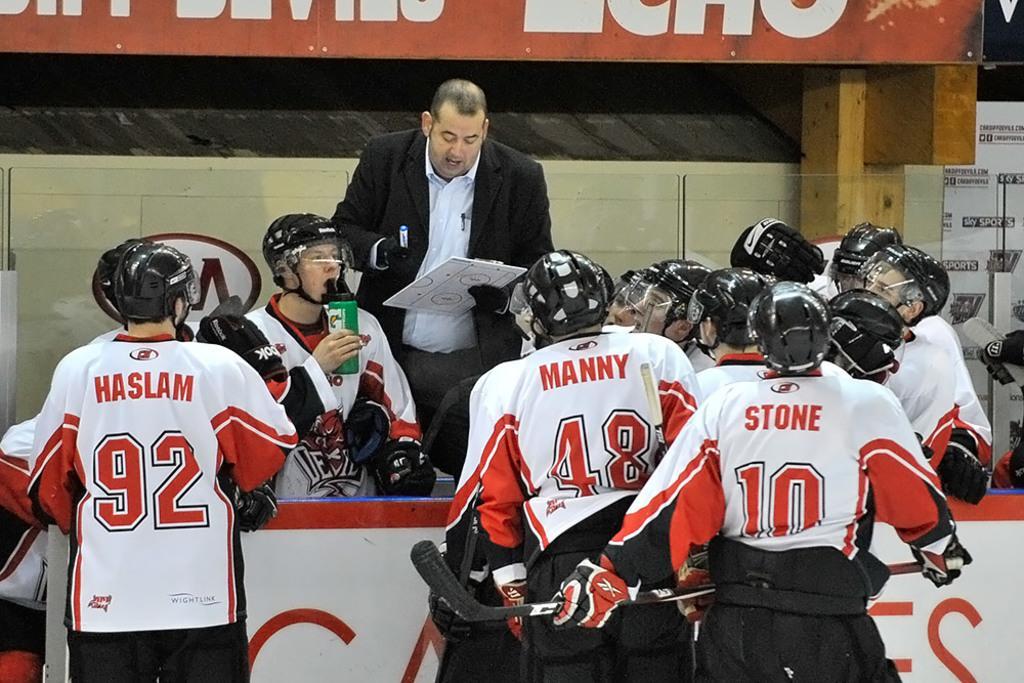How would you summarize this image in a sentence or two? In this image, we can see people wearing sports dress and are wearing helmets, gloves and holding some objects. In the background, there are boards with some text and there is a person wearing gloves and holding a pad and we can see some objects. 